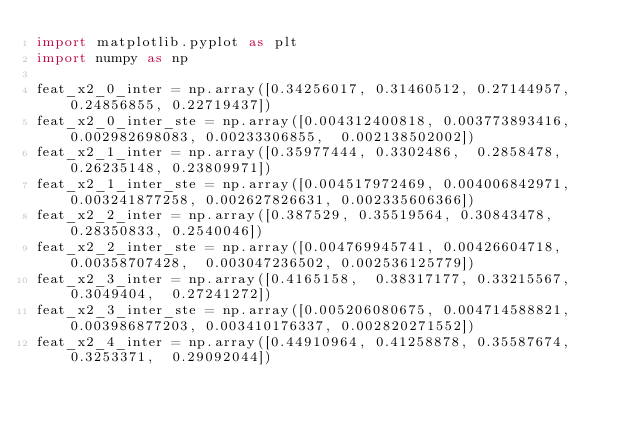Convert code to text. <code><loc_0><loc_0><loc_500><loc_500><_Python_>import matplotlib.pyplot as plt
import numpy as np

feat_x2_0_inter = np.array([0.34256017,	0.31460512,	0.27144957,	0.24856855,	0.22719437])
feat_x2_0_inter_ste = np.array([0.004312400818,	0.003773893416,	0.002982698083,	0.00233306855,	0.002138502002])
feat_x2_1_inter = np.array([0.35977444,	0.3302486,	0.2858478,	0.26235148,	0.23809971])
feat_x2_1_inter_ste = np.array([0.004517972469,	0.004006842971,	0.003241877258,	0.002627826631,	0.002335606366])
feat_x2_2_inter = np.array([0.387529,	0.35519564,	0.30843478,	0.28350833,	0.2540046])
feat_x2_2_inter_ste = np.array([0.004769945741,	0.00426604718,	0.00358707428,	0.003047236502,	0.002536125779])
feat_x2_3_inter = np.array([0.4165158,	0.38317177,	0.33215567,	0.3049404,	0.27241272])
feat_x2_3_inter_ste = np.array([0.005206080675,	0.004714588821,	0.003986877203,	0.003410176337,	0.002820271552])
feat_x2_4_inter = np.array([0.44910964,	0.41258878,	0.35587674,	0.3253371,	0.29092044])</code> 